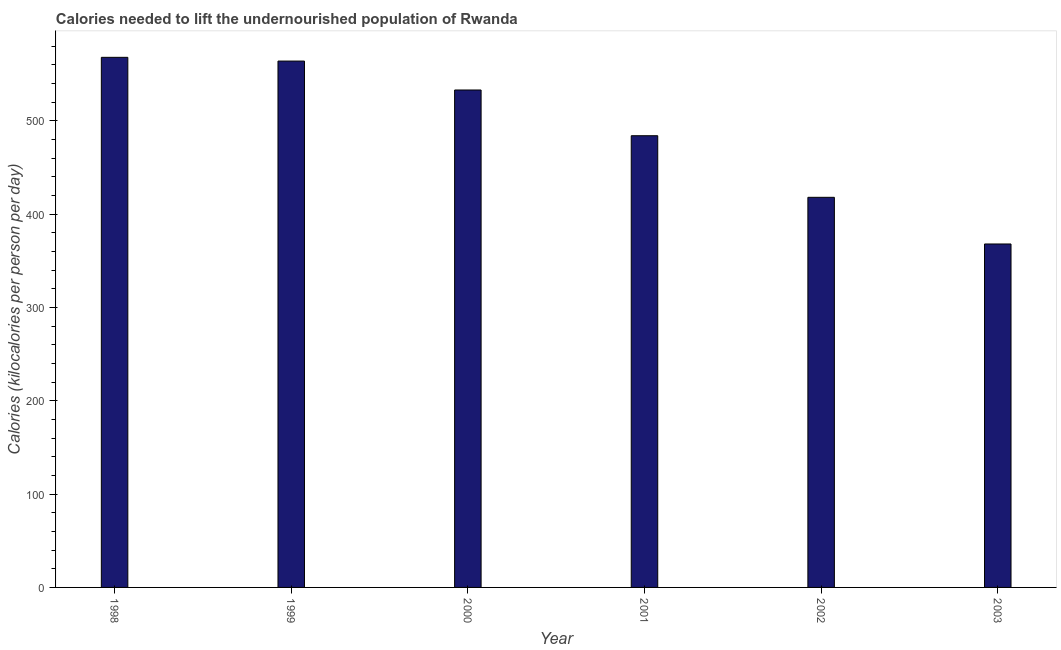Does the graph contain grids?
Offer a terse response. No. What is the title of the graph?
Provide a short and direct response. Calories needed to lift the undernourished population of Rwanda. What is the label or title of the Y-axis?
Give a very brief answer. Calories (kilocalories per person per day). What is the depth of food deficit in 2000?
Your answer should be very brief. 533. Across all years, what is the maximum depth of food deficit?
Keep it short and to the point. 568. Across all years, what is the minimum depth of food deficit?
Offer a terse response. 368. In which year was the depth of food deficit maximum?
Offer a terse response. 1998. In which year was the depth of food deficit minimum?
Your answer should be compact. 2003. What is the sum of the depth of food deficit?
Make the answer very short. 2935. What is the average depth of food deficit per year?
Your answer should be compact. 489. What is the median depth of food deficit?
Offer a terse response. 508.5. What is the ratio of the depth of food deficit in 1998 to that in 2001?
Provide a short and direct response. 1.17. What is the difference between the highest and the second highest depth of food deficit?
Keep it short and to the point. 4. Is the sum of the depth of food deficit in 1999 and 2003 greater than the maximum depth of food deficit across all years?
Offer a terse response. Yes. What is the difference between the highest and the lowest depth of food deficit?
Keep it short and to the point. 200. How many bars are there?
Your response must be concise. 6. What is the difference between two consecutive major ticks on the Y-axis?
Provide a succinct answer. 100. Are the values on the major ticks of Y-axis written in scientific E-notation?
Provide a short and direct response. No. What is the Calories (kilocalories per person per day) of 1998?
Make the answer very short. 568. What is the Calories (kilocalories per person per day) in 1999?
Give a very brief answer. 564. What is the Calories (kilocalories per person per day) in 2000?
Ensure brevity in your answer.  533. What is the Calories (kilocalories per person per day) of 2001?
Your answer should be very brief. 484. What is the Calories (kilocalories per person per day) of 2002?
Your answer should be very brief. 418. What is the Calories (kilocalories per person per day) of 2003?
Provide a succinct answer. 368. What is the difference between the Calories (kilocalories per person per day) in 1998 and 2000?
Offer a very short reply. 35. What is the difference between the Calories (kilocalories per person per day) in 1998 and 2001?
Your response must be concise. 84. What is the difference between the Calories (kilocalories per person per day) in 1998 and 2002?
Your answer should be very brief. 150. What is the difference between the Calories (kilocalories per person per day) in 1998 and 2003?
Your answer should be very brief. 200. What is the difference between the Calories (kilocalories per person per day) in 1999 and 2002?
Your response must be concise. 146. What is the difference between the Calories (kilocalories per person per day) in 1999 and 2003?
Your answer should be very brief. 196. What is the difference between the Calories (kilocalories per person per day) in 2000 and 2001?
Your answer should be very brief. 49. What is the difference between the Calories (kilocalories per person per day) in 2000 and 2002?
Make the answer very short. 115. What is the difference between the Calories (kilocalories per person per day) in 2000 and 2003?
Your answer should be very brief. 165. What is the difference between the Calories (kilocalories per person per day) in 2001 and 2002?
Make the answer very short. 66. What is the difference between the Calories (kilocalories per person per day) in 2001 and 2003?
Provide a succinct answer. 116. What is the difference between the Calories (kilocalories per person per day) in 2002 and 2003?
Provide a succinct answer. 50. What is the ratio of the Calories (kilocalories per person per day) in 1998 to that in 1999?
Provide a succinct answer. 1.01. What is the ratio of the Calories (kilocalories per person per day) in 1998 to that in 2000?
Make the answer very short. 1.07. What is the ratio of the Calories (kilocalories per person per day) in 1998 to that in 2001?
Your answer should be compact. 1.17. What is the ratio of the Calories (kilocalories per person per day) in 1998 to that in 2002?
Your answer should be compact. 1.36. What is the ratio of the Calories (kilocalories per person per day) in 1998 to that in 2003?
Make the answer very short. 1.54. What is the ratio of the Calories (kilocalories per person per day) in 1999 to that in 2000?
Your response must be concise. 1.06. What is the ratio of the Calories (kilocalories per person per day) in 1999 to that in 2001?
Provide a succinct answer. 1.17. What is the ratio of the Calories (kilocalories per person per day) in 1999 to that in 2002?
Your answer should be compact. 1.35. What is the ratio of the Calories (kilocalories per person per day) in 1999 to that in 2003?
Provide a succinct answer. 1.53. What is the ratio of the Calories (kilocalories per person per day) in 2000 to that in 2001?
Keep it short and to the point. 1.1. What is the ratio of the Calories (kilocalories per person per day) in 2000 to that in 2002?
Your answer should be very brief. 1.27. What is the ratio of the Calories (kilocalories per person per day) in 2000 to that in 2003?
Offer a terse response. 1.45. What is the ratio of the Calories (kilocalories per person per day) in 2001 to that in 2002?
Your answer should be very brief. 1.16. What is the ratio of the Calories (kilocalories per person per day) in 2001 to that in 2003?
Offer a very short reply. 1.31. What is the ratio of the Calories (kilocalories per person per day) in 2002 to that in 2003?
Your answer should be very brief. 1.14. 